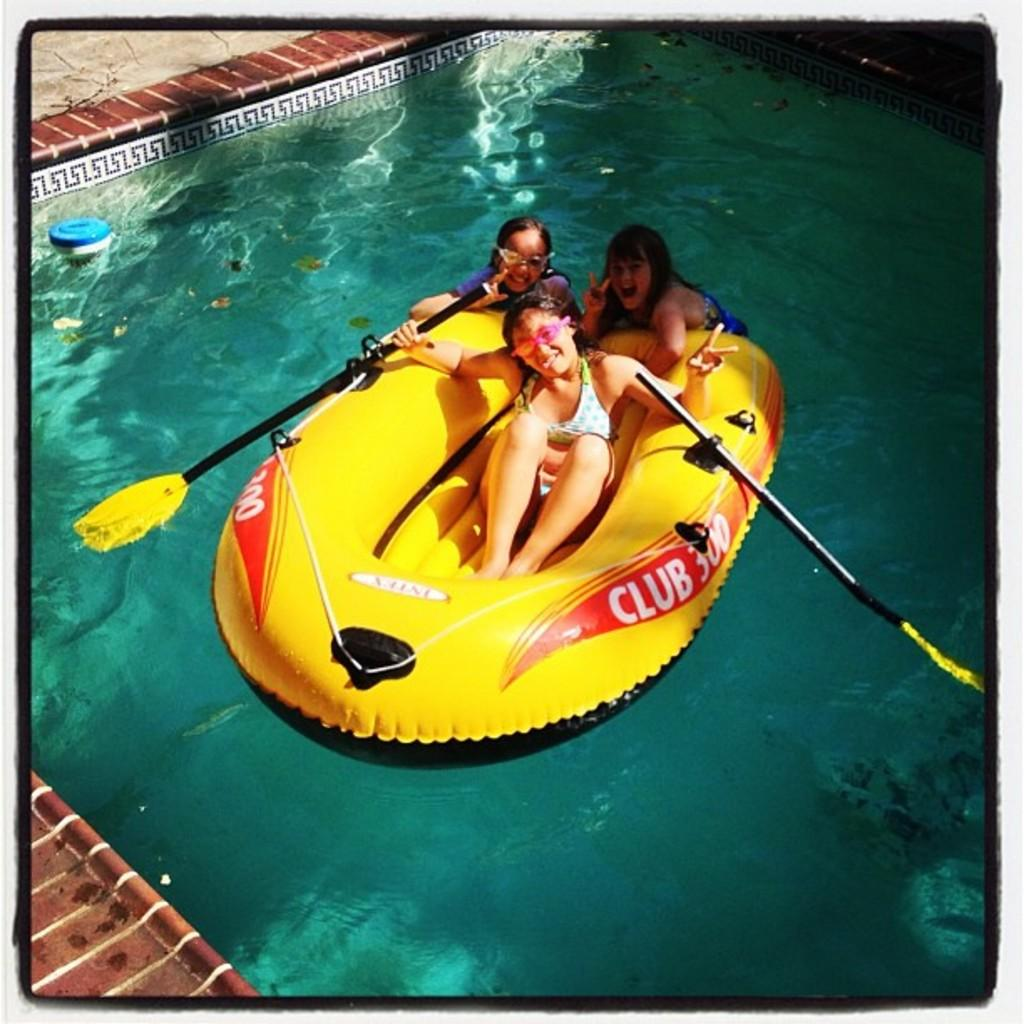How many girls are in the image? There are three small girls in the image. What are the girls doing in the image? The girls are sitting in a yellow color boat. What is the color of the boat the girls are sitting in? The boat is yellow. What can be seen in the background of the image? There is a swimming pool water visible in the image. What type of flooring is present in the image? There are brown color flooring tiles in the image. What type of ornament is hanging from the boat in the image? There is no ornament hanging from the boat in the image; it is a simple yellow boat with the girls sitting in it. 